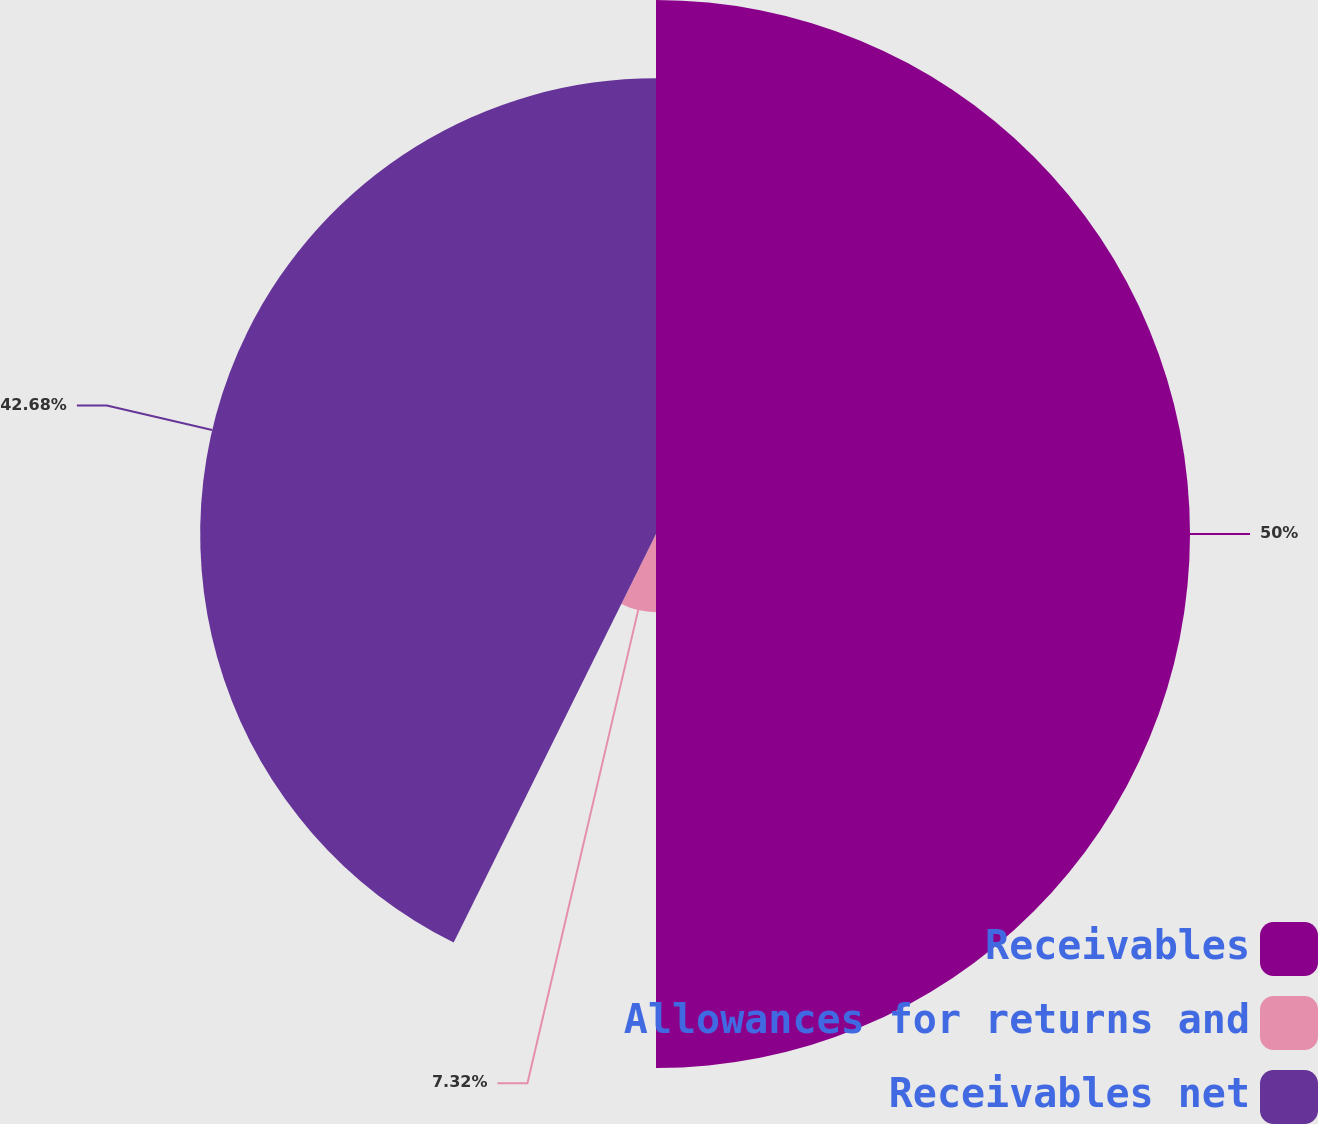Convert chart to OTSL. <chart><loc_0><loc_0><loc_500><loc_500><pie_chart><fcel>Receivables<fcel>Allowances for returns and<fcel>Receivables net<nl><fcel>50.0%<fcel>7.32%<fcel>42.68%<nl></chart> 